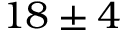<formula> <loc_0><loc_0><loc_500><loc_500>1 8 \pm 4</formula> 